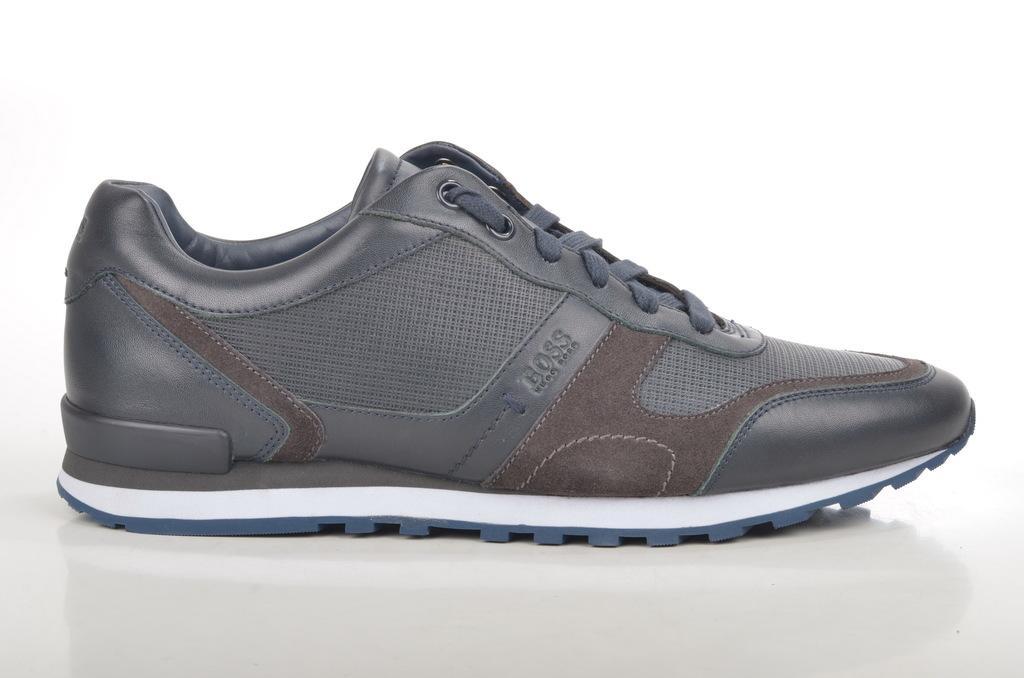Describe this image in one or two sentences. This is the image of the shoe. 